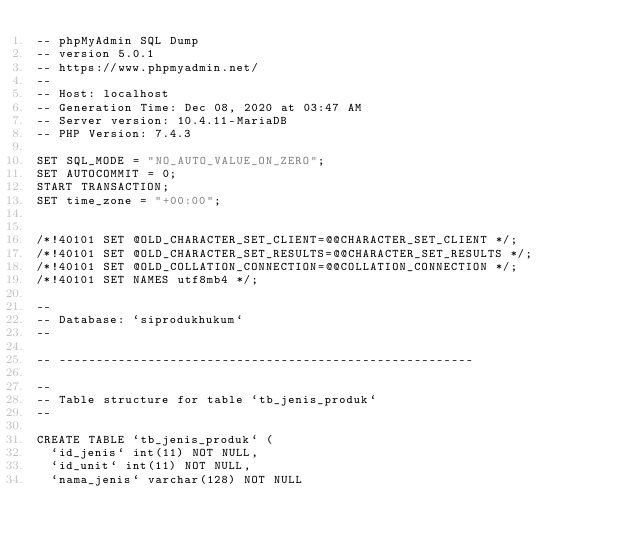<code> <loc_0><loc_0><loc_500><loc_500><_SQL_>-- phpMyAdmin SQL Dump
-- version 5.0.1
-- https://www.phpmyadmin.net/
--
-- Host: localhost
-- Generation Time: Dec 08, 2020 at 03:47 AM
-- Server version: 10.4.11-MariaDB
-- PHP Version: 7.4.3

SET SQL_MODE = "NO_AUTO_VALUE_ON_ZERO";
SET AUTOCOMMIT = 0;
START TRANSACTION;
SET time_zone = "+00:00";


/*!40101 SET @OLD_CHARACTER_SET_CLIENT=@@CHARACTER_SET_CLIENT */;
/*!40101 SET @OLD_CHARACTER_SET_RESULTS=@@CHARACTER_SET_RESULTS */;
/*!40101 SET @OLD_COLLATION_CONNECTION=@@COLLATION_CONNECTION */;
/*!40101 SET NAMES utf8mb4 */;

--
-- Database: `siprodukhukum`
--

-- --------------------------------------------------------

--
-- Table structure for table `tb_jenis_produk`
--

CREATE TABLE `tb_jenis_produk` (
  `id_jenis` int(11) NOT NULL,
  `id_unit` int(11) NOT NULL,
  `nama_jenis` varchar(128) NOT NULL</code> 